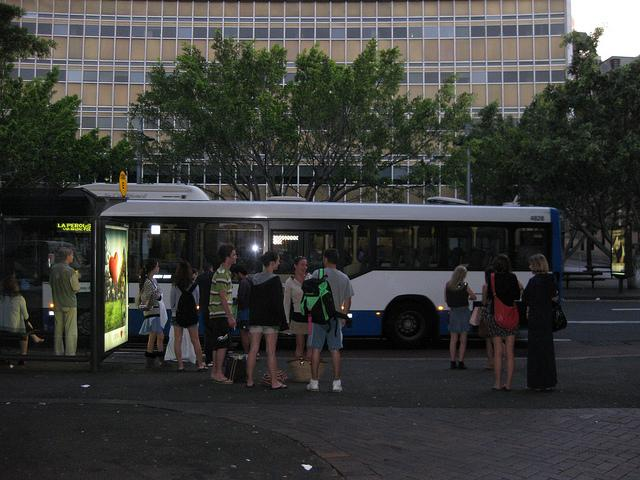Why are they standing on the sidewalk?

Choices:
A) lost
B) taking bus
C) taking cab
D) socializing taking bus 